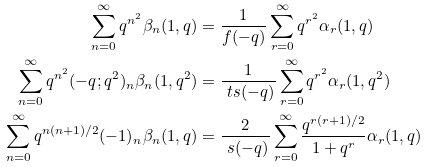<formula> <loc_0><loc_0><loc_500><loc_500>\sum _ { n = 0 } ^ { \infty } q ^ { n ^ { 2 } } \beta _ { n } ( 1 , q ) & = \frac { 1 } { f ( - q ) } \sum _ { r = 0 } ^ { \infty } q ^ { r ^ { 2 } } \alpha _ { r } ( 1 , q ) \\ \sum _ { n = 0 } ^ { \infty } q ^ { n ^ { 2 } } ( - q ; q ^ { 2 } ) _ { n } \beta _ { n } ( 1 , q ^ { 2 } ) & = \frac { 1 } { \ t s ( - q ) } \sum _ { r = 0 } ^ { \infty } q ^ { r ^ { 2 } } \alpha _ { r } ( 1 , q ^ { 2 } ) \\ \sum _ { n = 0 } ^ { \infty } q ^ { n ( n + 1 ) / 2 } ( - 1 ) _ { n } \beta _ { n } ( 1 , q ) & = \frac { 2 } { \ s ( - q ) } \sum _ { r = 0 } ^ { \infty } \frac { q ^ { r ( r + 1 ) / 2 } } { 1 + q ^ { r } } \alpha _ { r } ( 1 , q )</formula> 